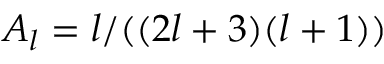Convert formula to latex. <formula><loc_0><loc_0><loc_500><loc_500>A _ { l } = l / ( ( 2 l + 3 ) ( l + 1 ) )</formula> 